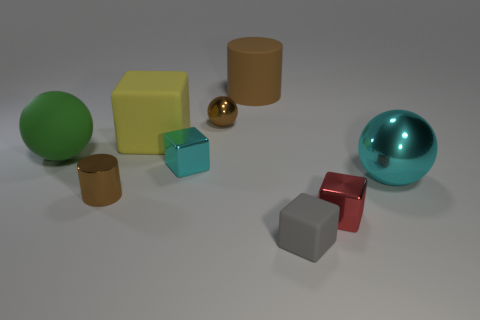Subtract all purple cubes. Subtract all blue cylinders. How many cubes are left? 4 Add 1 big yellow things. How many objects exist? 10 Subtract all cubes. How many objects are left? 5 Subtract all small brown balls. Subtract all big brown things. How many objects are left? 7 Add 7 cyan objects. How many cyan objects are left? 9 Add 7 brown metallic things. How many brown metallic things exist? 9 Subtract 0 red cylinders. How many objects are left? 9 